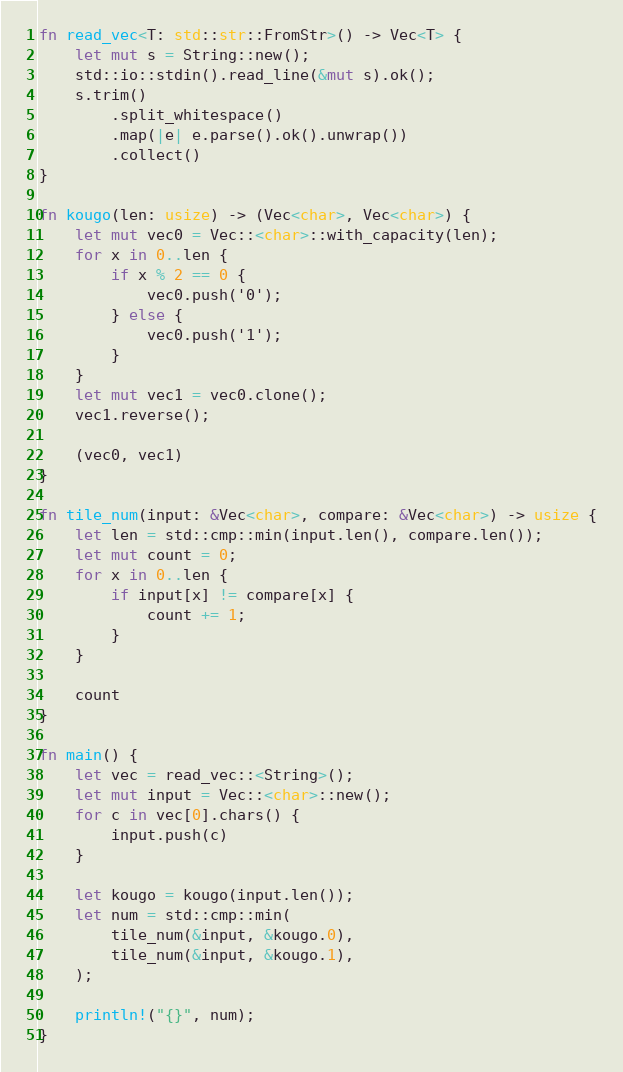<code> <loc_0><loc_0><loc_500><loc_500><_Rust_>fn read_vec<T: std::str::FromStr>() -> Vec<T> {
    let mut s = String::new();
    std::io::stdin().read_line(&mut s).ok();
    s.trim()
        .split_whitespace()
        .map(|e| e.parse().ok().unwrap())
        .collect()
}

fn kougo(len: usize) -> (Vec<char>, Vec<char>) {
    let mut vec0 = Vec::<char>::with_capacity(len);
    for x in 0..len {
        if x % 2 == 0 {
            vec0.push('0');
        } else {
            vec0.push('1');
        }
    }
    let mut vec1 = vec0.clone();
    vec1.reverse();

    (vec0, vec1)
}

fn tile_num(input: &Vec<char>, compare: &Vec<char>) -> usize {
    let len = std::cmp::min(input.len(), compare.len());
    let mut count = 0;
    for x in 0..len {
        if input[x] != compare[x] {
            count += 1;
        }
    }

    count
}

fn main() {
    let vec = read_vec::<String>();
    let mut input = Vec::<char>::new();
    for c in vec[0].chars() {
        input.push(c)
    }

    let kougo = kougo(input.len());
    let num = std::cmp::min(
        tile_num(&input, &kougo.0),
        tile_num(&input, &kougo.1),
    );

    println!("{}", num);
}
</code> 